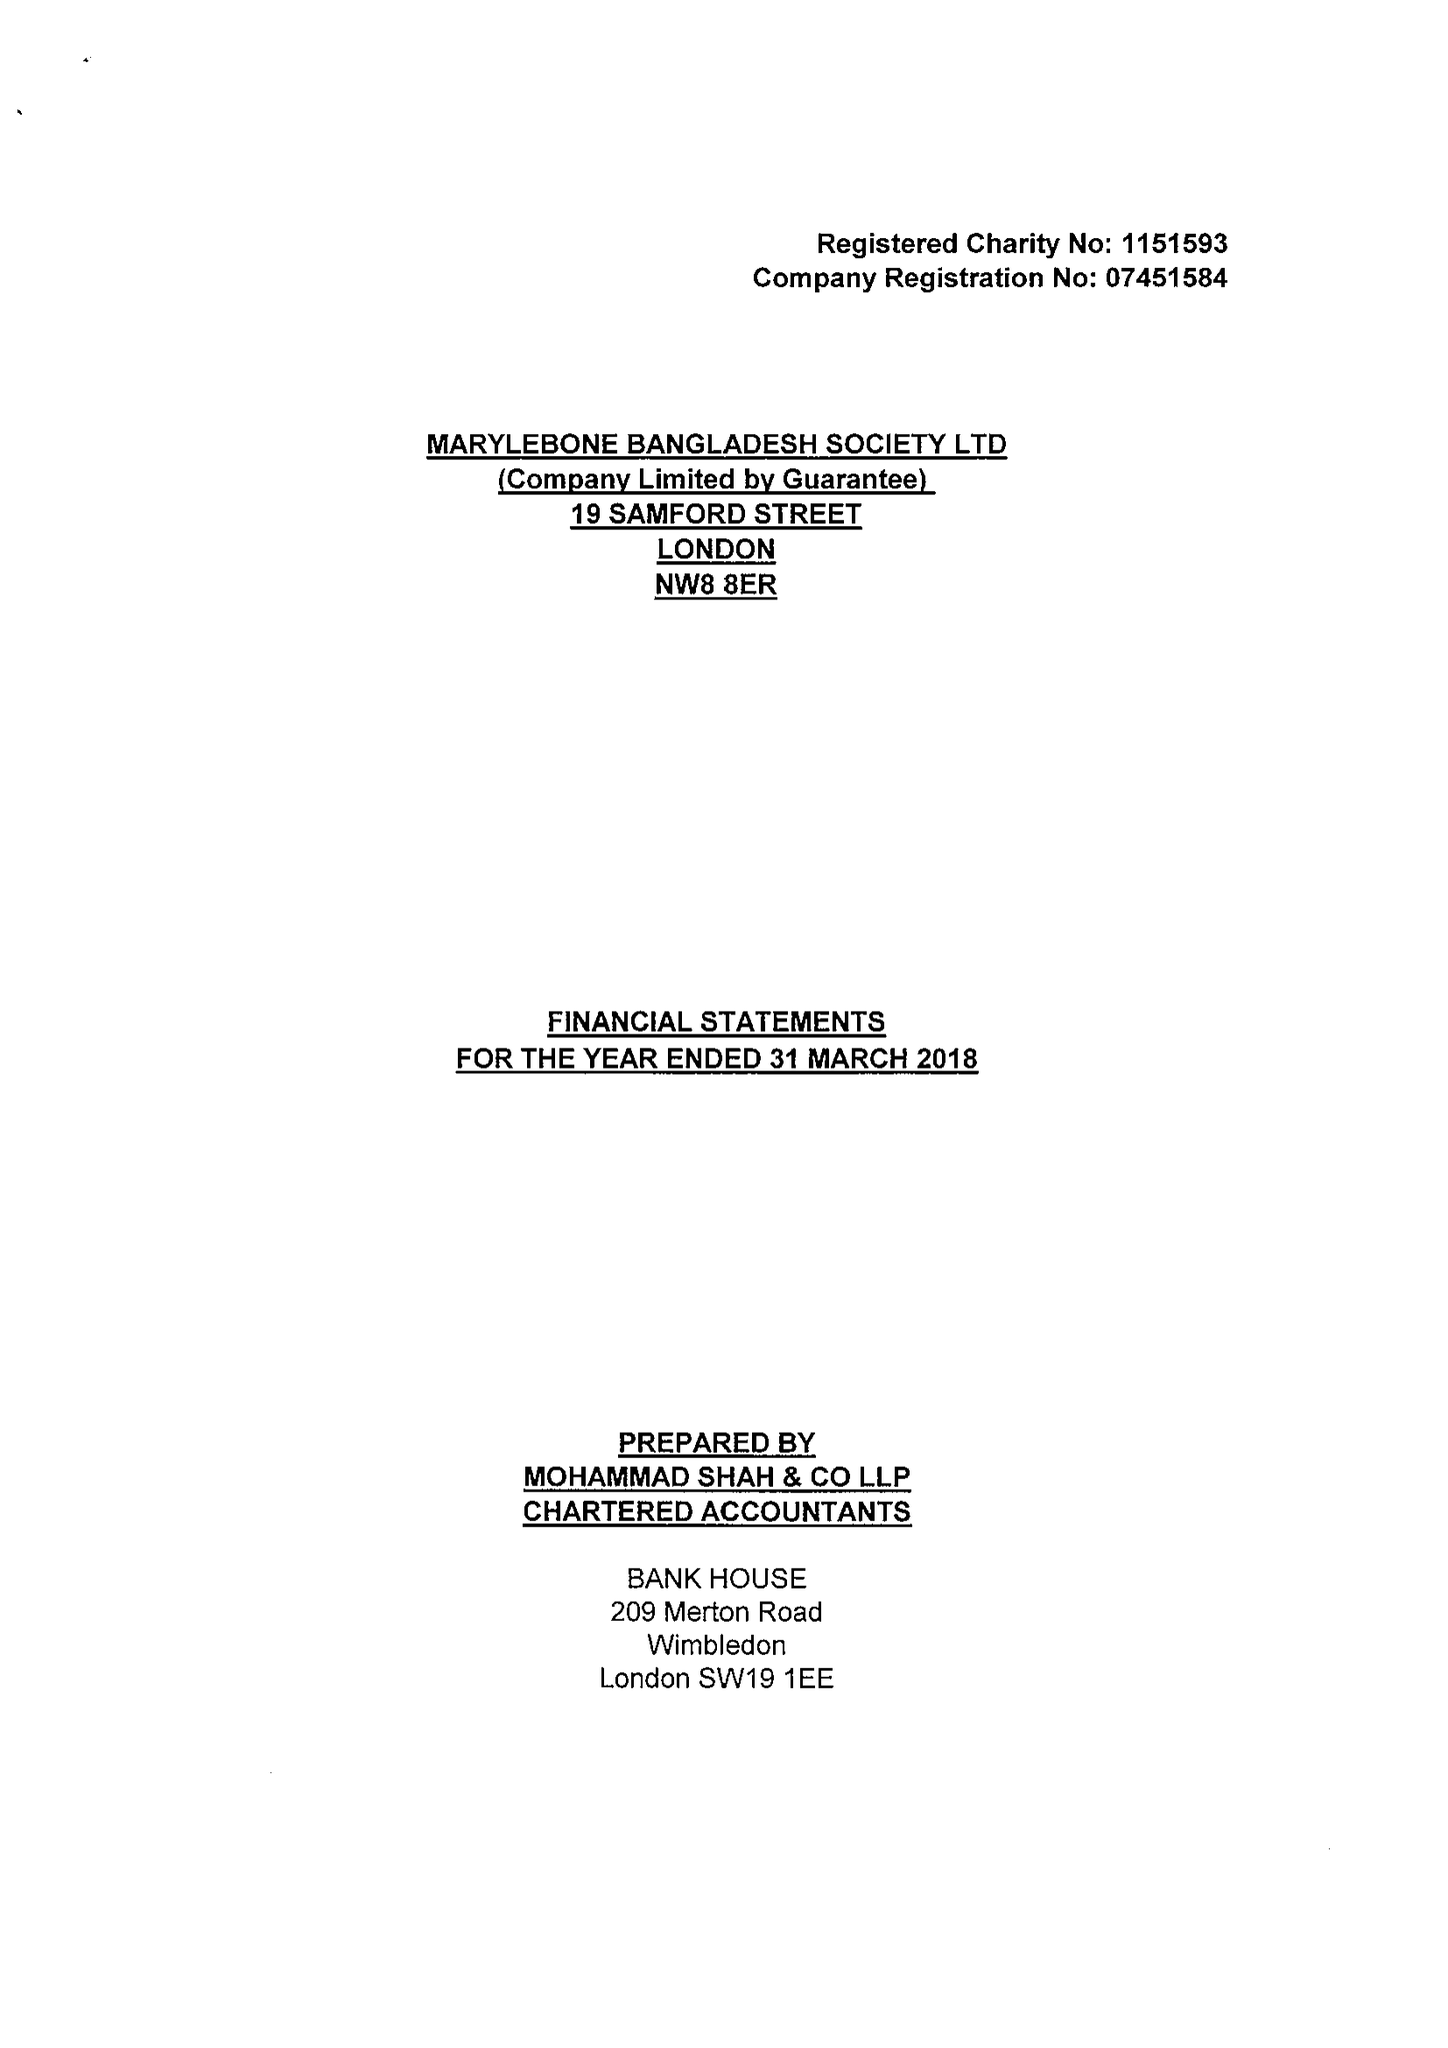What is the value for the report_date?
Answer the question using a single word or phrase. 2018-03-31 